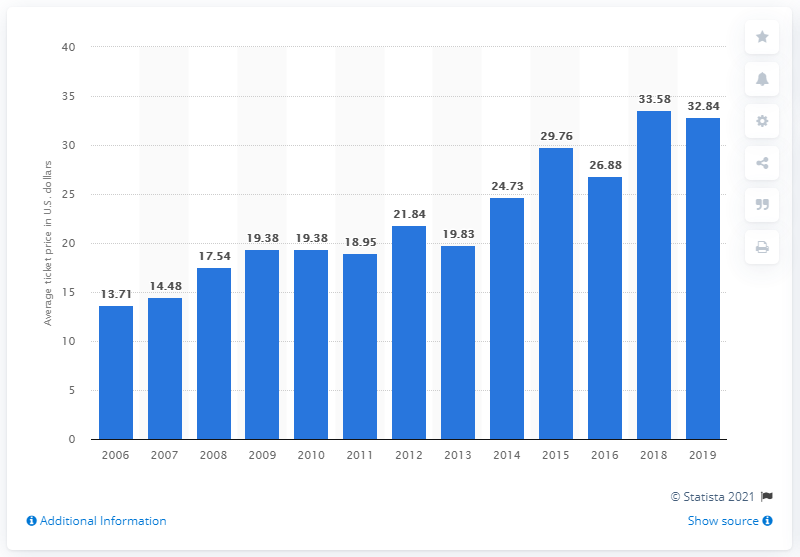Draw attention to some important aspects in this diagram. In 2019, the average ticket price for Kansas City Royals games was $32.84. 